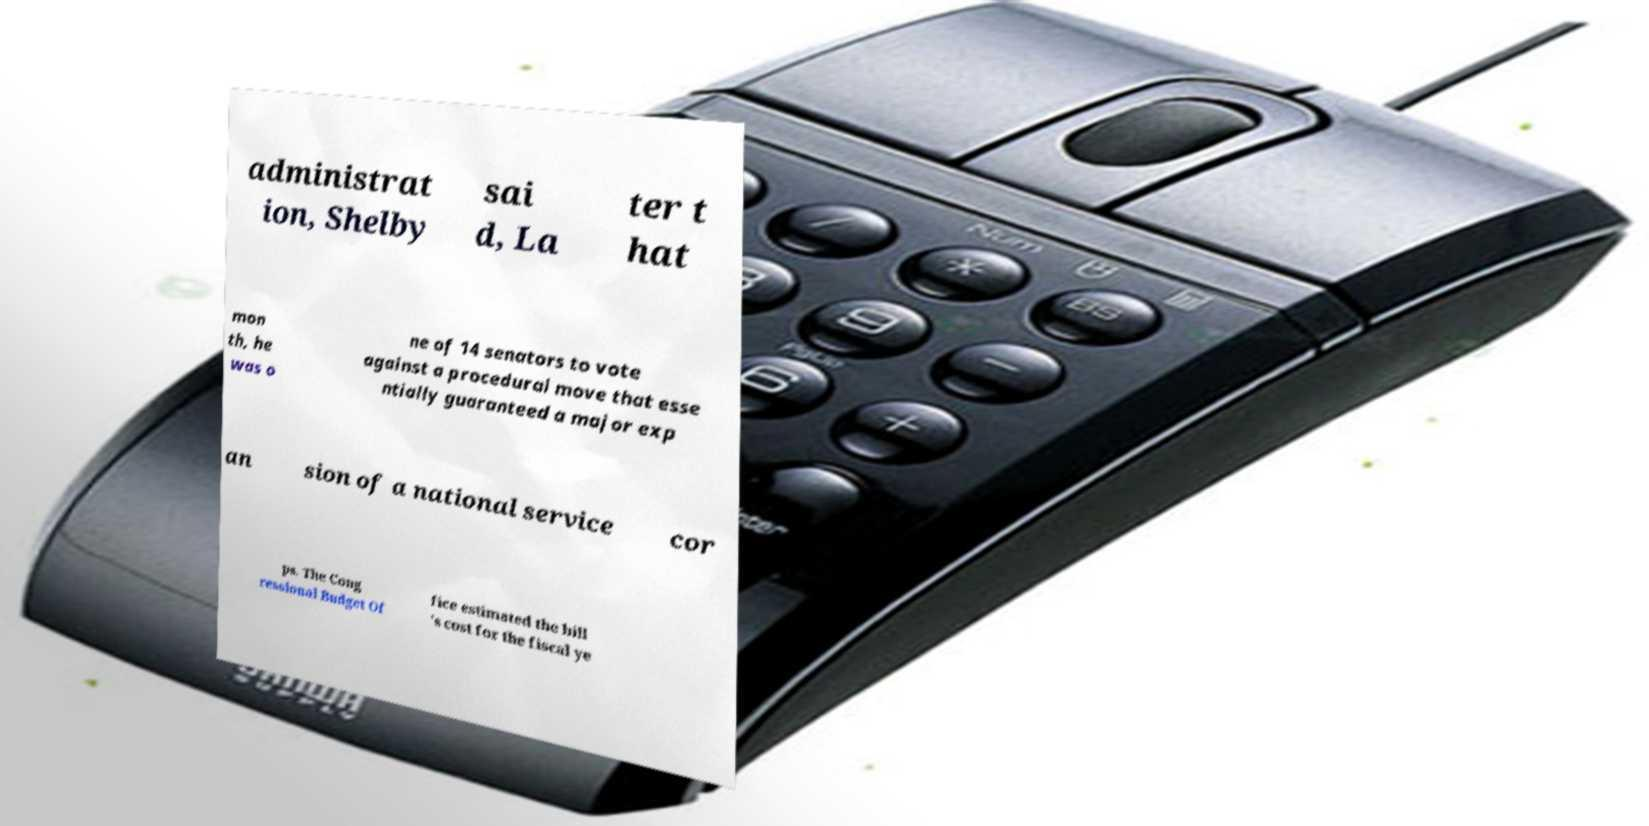What messages or text are displayed in this image? I need them in a readable, typed format. administrat ion, Shelby sai d, La ter t hat mon th, he was o ne of 14 senators to vote against a procedural move that esse ntially guaranteed a major exp an sion of a national service cor ps. The Cong ressional Budget Of fice estimated the bill 's cost for the fiscal ye 